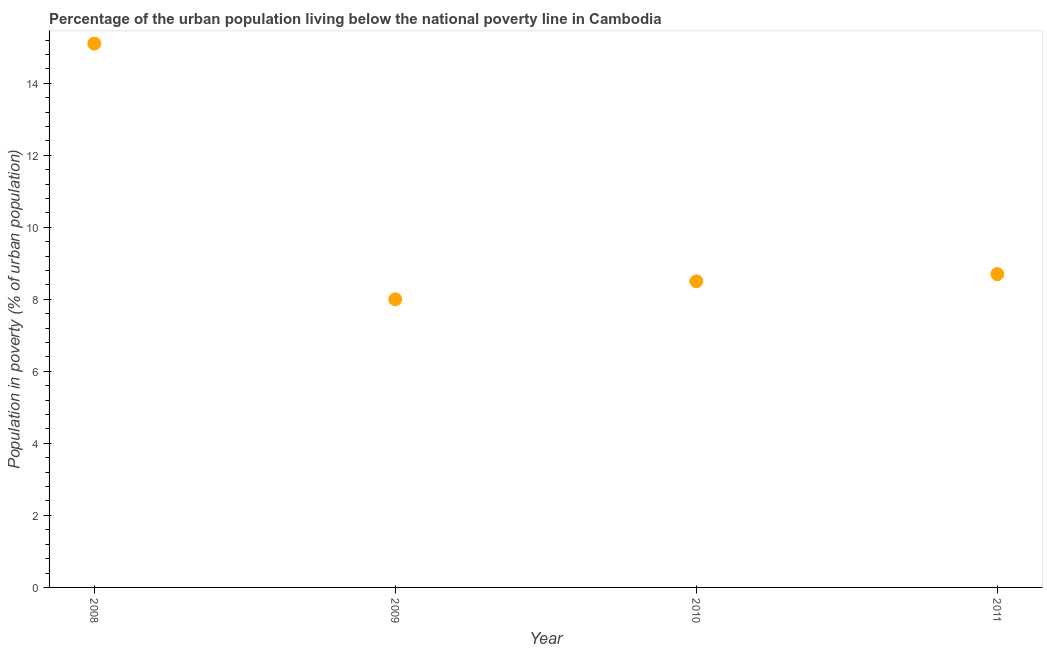What is the percentage of urban population living below poverty line in 2010?
Ensure brevity in your answer.  8.5. What is the sum of the percentage of urban population living below poverty line?
Keep it short and to the point. 40.3. What is the difference between the percentage of urban population living below poverty line in 2009 and 2011?
Give a very brief answer. -0.7. What is the average percentage of urban population living below poverty line per year?
Your answer should be compact. 10.07. Do a majority of the years between 2010 and 2008 (inclusive) have percentage of urban population living below poverty line greater than 5.2 %?
Your answer should be very brief. No. What is the ratio of the percentage of urban population living below poverty line in 2008 to that in 2010?
Make the answer very short. 1.78. Is the percentage of urban population living below poverty line in 2008 less than that in 2010?
Keep it short and to the point. No. Is the difference between the percentage of urban population living below poverty line in 2008 and 2009 greater than the difference between any two years?
Keep it short and to the point. Yes. What is the difference between the highest and the second highest percentage of urban population living below poverty line?
Your answer should be compact. 6.4. Is the sum of the percentage of urban population living below poverty line in 2008 and 2009 greater than the maximum percentage of urban population living below poverty line across all years?
Make the answer very short. Yes. What is the difference between the highest and the lowest percentage of urban population living below poverty line?
Your answer should be compact. 7.1. Does the percentage of urban population living below poverty line monotonically increase over the years?
Give a very brief answer. No. How many dotlines are there?
Your answer should be compact. 1. How many years are there in the graph?
Offer a very short reply. 4. What is the difference between two consecutive major ticks on the Y-axis?
Give a very brief answer. 2. Does the graph contain grids?
Give a very brief answer. No. What is the title of the graph?
Your answer should be very brief. Percentage of the urban population living below the national poverty line in Cambodia. What is the label or title of the Y-axis?
Offer a terse response. Population in poverty (% of urban population). What is the Population in poverty (% of urban population) in 2008?
Offer a very short reply. 15.1. What is the Population in poverty (% of urban population) in 2010?
Give a very brief answer. 8.5. What is the Population in poverty (% of urban population) in 2011?
Ensure brevity in your answer.  8.7. What is the difference between the Population in poverty (% of urban population) in 2008 and 2009?
Make the answer very short. 7.1. What is the difference between the Population in poverty (% of urban population) in 2008 and 2010?
Your response must be concise. 6.6. What is the difference between the Population in poverty (% of urban population) in 2009 and 2010?
Make the answer very short. -0.5. What is the difference between the Population in poverty (% of urban population) in 2009 and 2011?
Your response must be concise. -0.7. What is the ratio of the Population in poverty (% of urban population) in 2008 to that in 2009?
Make the answer very short. 1.89. What is the ratio of the Population in poverty (% of urban population) in 2008 to that in 2010?
Your response must be concise. 1.78. What is the ratio of the Population in poverty (% of urban population) in 2008 to that in 2011?
Provide a short and direct response. 1.74. What is the ratio of the Population in poverty (% of urban population) in 2009 to that in 2010?
Offer a terse response. 0.94. What is the ratio of the Population in poverty (% of urban population) in 2009 to that in 2011?
Provide a succinct answer. 0.92. What is the ratio of the Population in poverty (% of urban population) in 2010 to that in 2011?
Offer a terse response. 0.98. 